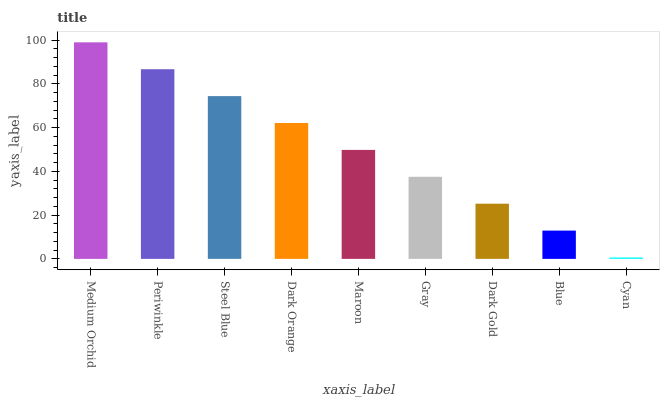Is Cyan the minimum?
Answer yes or no. Yes. Is Medium Orchid the maximum?
Answer yes or no. Yes. Is Periwinkle the minimum?
Answer yes or no. No. Is Periwinkle the maximum?
Answer yes or no. No. Is Medium Orchid greater than Periwinkle?
Answer yes or no. Yes. Is Periwinkle less than Medium Orchid?
Answer yes or no. Yes. Is Periwinkle greater than Medium Orchid?
Answer yes or no. No. Is Medium Orchid less than Periwinkle?
Answer yes or no. No. Is Maroon the high median?
Answer yes or no. Yes. Is Maroon the low median?
Answer yes or no. Yes. Is Gray the high median?
Answer yes or no. No. Is Cyan the low median?
Answer yes or no. No. 